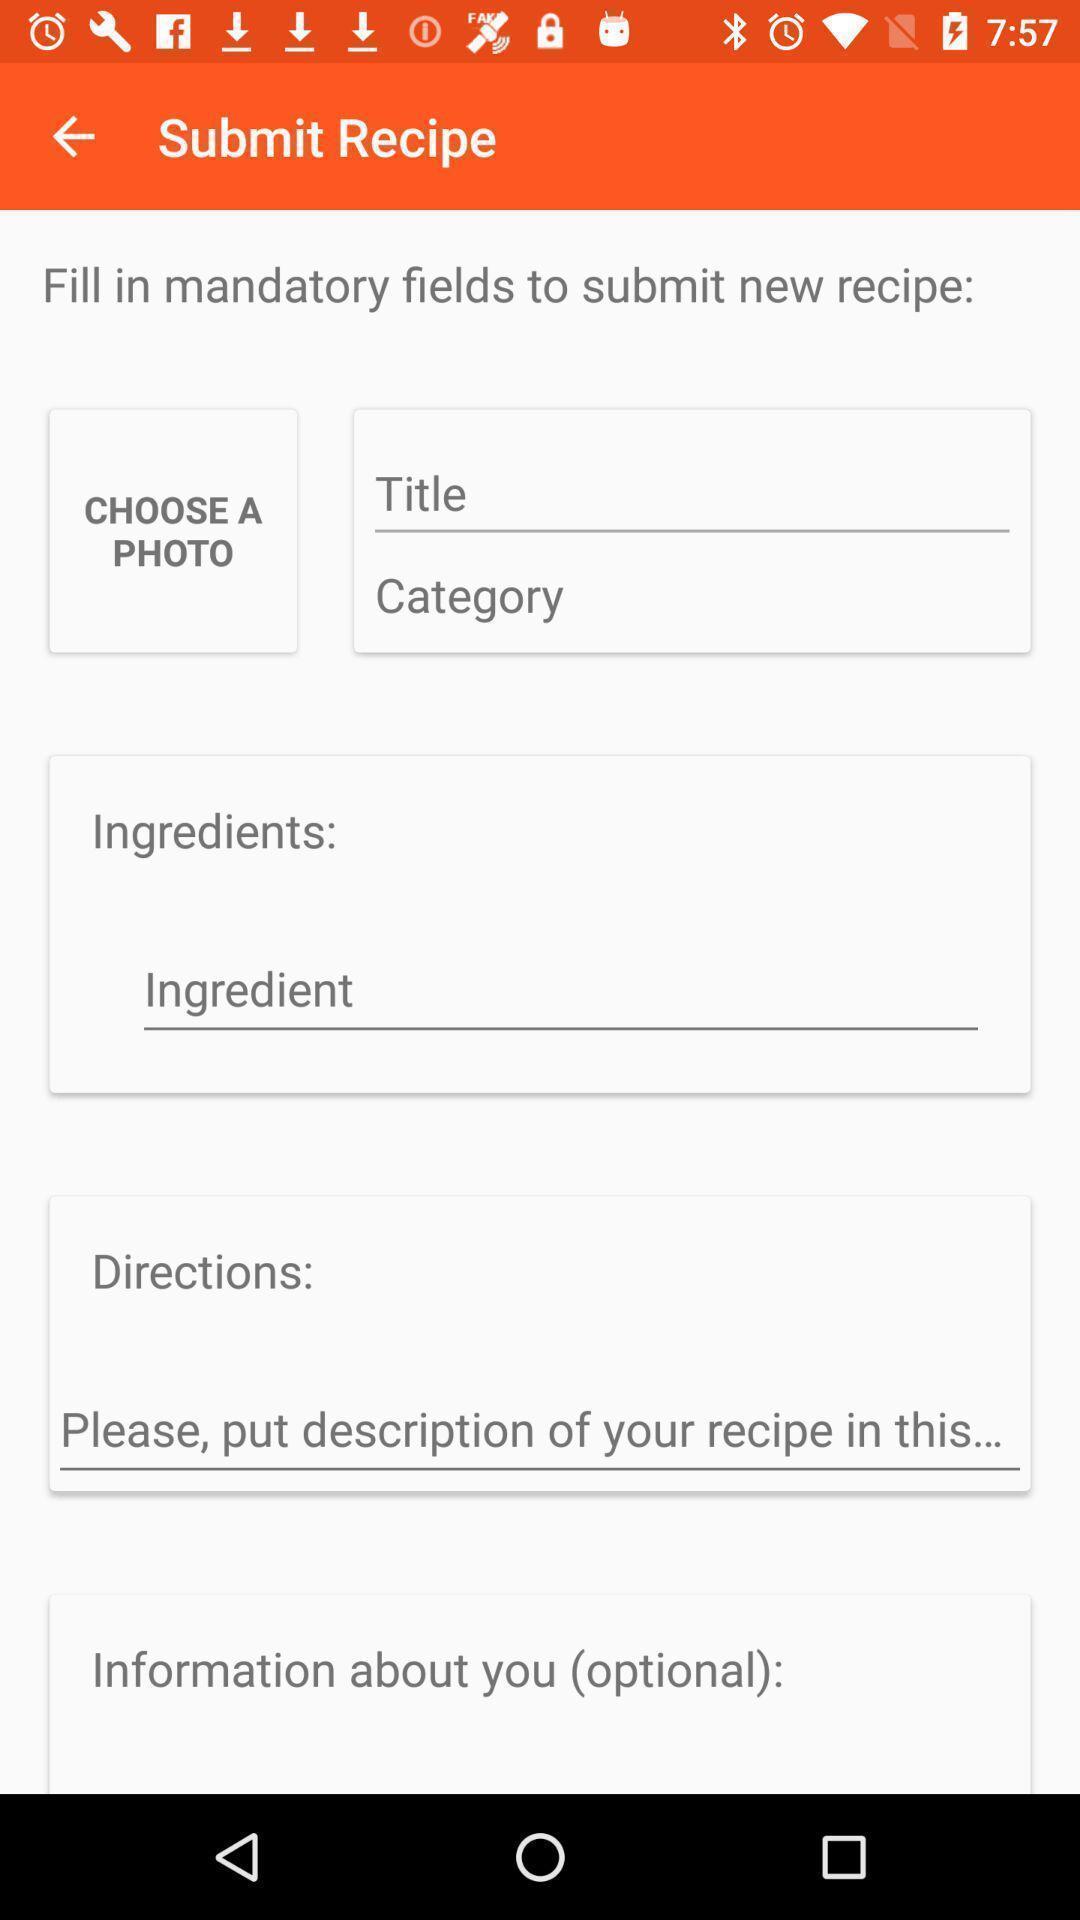Provide a detailed account of this screenshot. Screen displaying to submit recipe. 